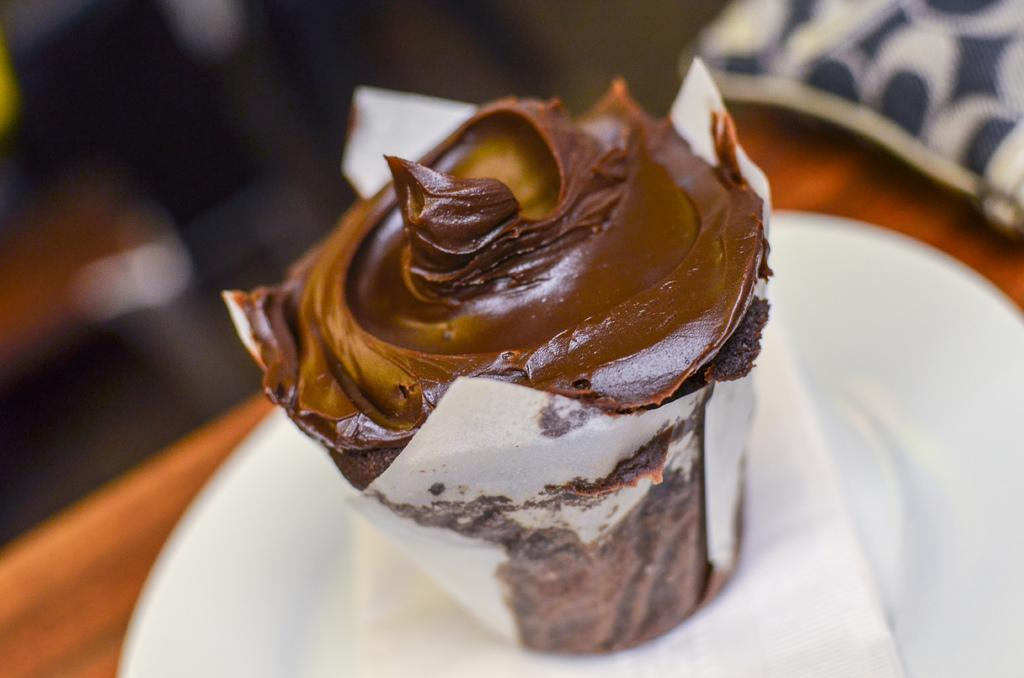What type of food is visible in the image? There is a cupcake in the image. What other item can be seen in the image besides the cupcake? There is a tissue paper in the image. Where are the cupcake and tissue paper located? Both the cupcake and tissue paper are on a plate. How would you describe the background of the image? The background of the image is blurred. What type of plantation can be seen in the background of the image? There is no plantation visible in the image; the background is blurred. How many zebras are present in the image? There are no zebras present in the image; it features a cupcake, tissue paper, and a plate. 